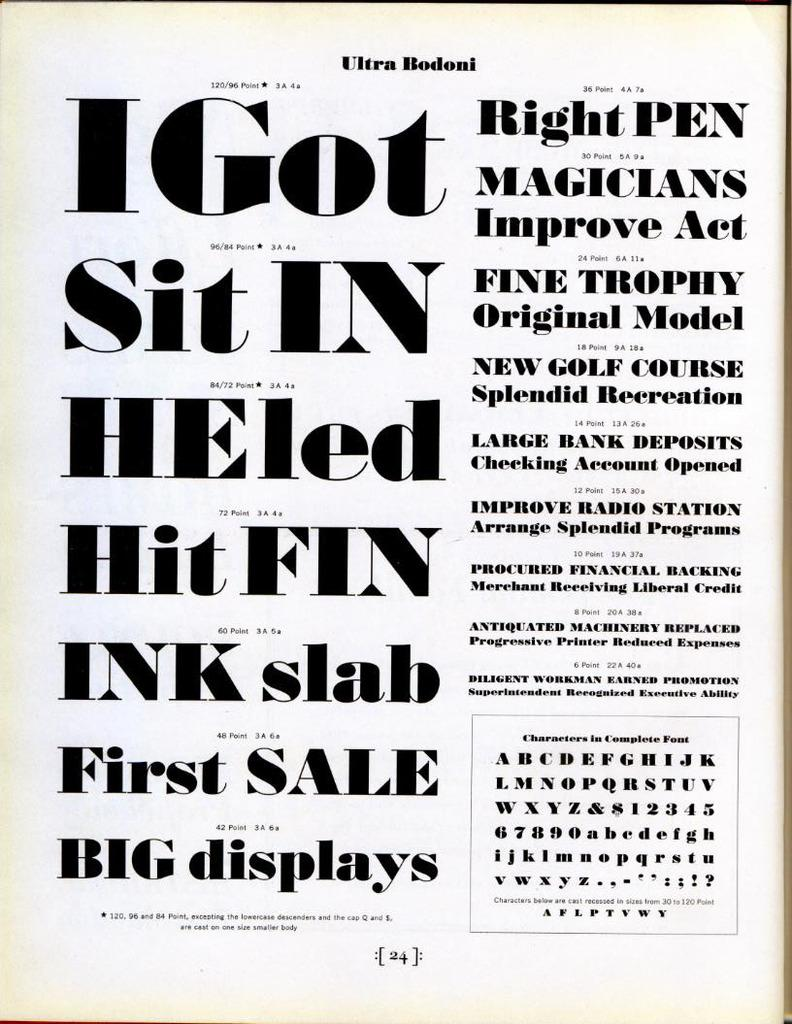<image>
Relay a brief, clear account of the picture shown. A page shows different fonts and is titled Ultra Bodoni. 